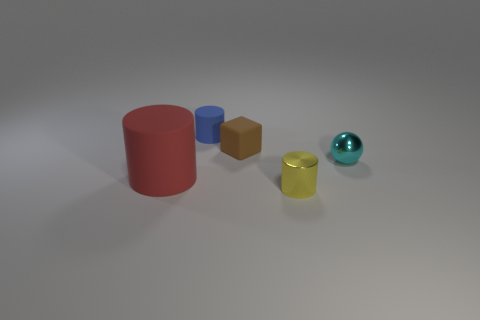Add 1 big cyan matte cubes. How many objects exist? 6 Subtract all cylinders. How many objects are left? 2 Subtract all large rubber spheres. Subtract all red things. How many objects are left? 4 Add 5 small brown rubber things. How many small brown rubber things are left? 6 Add 5 cylinders. How many cylinders exist? 8 Subtract 0 yellow blocks. How many objects are left? 5 